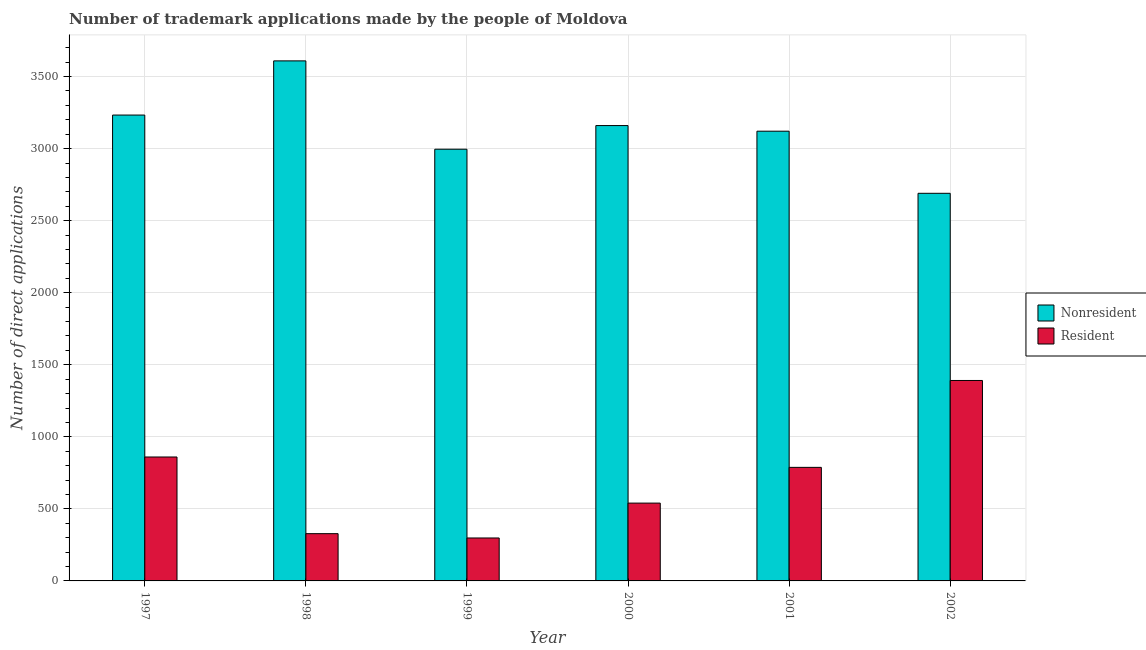Are the number of bars per tick equal to the number of legend labels?
Provide a succinct answer. Yes. Are the number of bars on each tick of the X-axis equal?
Offer a very short reply. Yes. How many bars are there on the 6th tick from the left?
Give a very brief answer. 2. How many bars are there on the 1st tick from the right?
Your answer should be very brief. 2. In how many cases, is the number of bars for a given year not equal to the number of legend labels?
Make the answer very short. 0. What is the number of trademark applications made by residents in 1998?
Your answer should be very brief. 328. Across all years, what is the maximum number of trademark applications made by residents?
Offer a very short reply. 1391. Across all years, what is the minimum number of trademark applications made by residents?
Provide a short and direct response. 298. In which year was the number of trademark applications made by residents minimum?
Give a very brief answer. 1999. What is the total number of trademark applications made by residents in the graph?
Give a very brief answer. 4205. What is the difference between the number of trademark applications made by non residents in 1998 and that in 2001?
Offer a very short reply. 488. What is the difference between the number of trademark applications made by non residents in 2000 and the number of trademark applications made by residents in 1998?
Offer a very short reply. -449. What is the average number of trademark applications made by non residents per year?
Offer a terse response. 3134.83. In how many years, is the number of trademark applications made by non residents greater than 1700?
Give a very brief answer. 6. What is the ratio of the number of trademark applications made by residents in 1999 to that in 2000?
Your answer should be compact. 0.55. What is the difference between the highest and the second highest number of trademark applications made by non residents?
Your response must be concise. 376. What is the difference between the highest and the lowest number of trademark applications made by residents?
Provide a succinct answer. 1093. Is the sum of the number of trademark applications made by residents in 1997 and 2001 greater than the maximum number of trademark applications made by non residents across all years?
Your response must be concise. Yes. What does the 2nd bar from the left in 1997 represents?
Keep it short and to the point. Resident. What does the 2nd bar from the right in 2001 represents?
Offer a very short reply. Nonresident. Are all the bars in the graph horizontal?
Provide a short and direct response. No. How many years are there in the graph?
Make the answer very short. 6. Are the values on the major ticks of Y-axis written in scientific E-notation?
Your response must be concise. No. Where does the legend appear in the graph?
Provide a short and direct response. Center right. How are the legend labels stacked?
Give a very brief answer. Vertical. What is the title of the graph?
Offer a very short reply. Number of trademark applications made by the people of Moldova. What is the label or title of the X-axis?
Your response must be concise. Year. What is the label or title of the Y-axis?
Your answer should be very brief. Number of direct applications. What is the Number of direct applications in Nonresident in 1997?
Your response must be concise. 3233. What is the Number of direct applications in Resident in 1997?
Offer a terse response. 860. What is the Number of direct applications in Nonresident in 1998?
Keep it short and to the point. 3609. What is the Number of direct applications of Resident in 1998?
Provide a short and direct response. 328. What is the Number of direct applications in Nonresident in 1999?
Offer a very short reply. 2996. What is the Number of direct applications of Resident in 1999?
Give a very brief answer. 298. What is the Number of direct applications of Nonresident in 2000?
Offer a terse response. 3160. What is the Number of direct applications in Resident in 2000?
Your response must be concise. 540. What is the Number of direct applications in Nonresident in 2001?
Provide a succinct answer. 3121. What is the Number of direct applications in Resident in 2001?
Provide a succinct answer. 788. What is the Number of direct applications of Nonresident in 2002?
Your response must be concise. 2690. What is the Number of direct applications of Resident in 2002?
Your answer should be very brief. 1391. Across all years, what is the maximum Number of direct applications of Nonresident?
Your answer should be very brief. 3609. Across all years, what is the maximum Number of direct applications of Resident?
Make the answer very short. 1391. Across all years, what is the minimum Number of direct applications in Nonresident?
Your response must be concise. 2690. Across all years, what is the minimum Number of direct applications of Resident?
Your answer should be very brief. 298. What is the total Number of direct applications of Nonresident in the graph?
Make the answer very short. 1.88e+04. What is the total Number of direct applications in Resident in the graph?
Your answer should be very brief. 4205. What is the difference between the Number of direct applications of Nonresident in 1997 and that in 1998?
Your answer should be compact. -376. What is the difference between the Number of direct applications in Resident in 1997 and that in 1998?
Keep it short and to the point. 532. What is the difference between the Number of direct applications of Nonresident in 1997 and that in 1999?
Make the answer very short. 237. What is the difference between the Number of direct applications of Resident in 1997 and that in 1999?
Offer a terse response. 562. What is the difference between the Number of direct applications of Resident in 1997 and that in 2000?
Ensure brevity in your answer.  320. What is the difference between the Number of direct applications of Nonresident in 1997 and that in 2001?
Offer a terse response. 112. What is the difference between the Number of direct applications in Nonresident in 1997 and that in 2002?
Provide a succinct answer. 543. What is the difference between the Number of direct applications in Resident in 1997 and that in 2002?
Make the answer very short. -531. What is the difference between the Number of direct applications of Nonresident in 1998 and that in 1999?
Make the answer very short. 613. What is the difference between the Number of direct applications of Nonresident in 1998 and that in 2000?
Your answer should be very brief. 449. What is the difference between the Number of direct applications of Resident in 1998 and that in 2000?
Your answer should be very brief. -212. What is the difference between the Number of direct applications of Nonresident in 1998 and that in 2001?
Give a very brief answer. 488. What is the difference between the Number of direct applications in Resident in 1998 and that in 2001?
Offer a very short reply. -460. What is the difference between the Number of direct applications of Nonresident in 1998 and that in 2002?
Keep it short and to the point. 919. What is the difference between the Number of direct applications in Resident in 1998 and that in 2002?
Your answer should be compact. -1063. What is the difference between the Number of direct applications in Nonresident in 1999 and that in 2000?
Your response must be concise. -164. What is the difference between the Number of direct applications of Resident in 1999 and that in 2000?
Provide a succinct answer. -242. What is the difference between the Number of direct applications in Nonresident in 1999 and that in 2001?
Ensure brevity in your answer.  -125. What is the difference between the Number of direct applications in Resident in 1999 and that in 2001?
Offer a very short reply. -490. What is the difference between the Number of direct applications in Nonresident in 1999 and that in 2002?
Offer a terse response. 306. What is the difference between the Number of direct applications in Resident in 1999 and that in 2002?
Keep it short and to the point. -1093. What is the difference between the Number of direct applications of Resident in 2000 and that in 2001?
Your answer should be compact. -248. What is the difference between the Number of direct applications in Nonresident in 2000 and that in 2002?
Provide a short and direct response. 470. What is the difference between the Number of direct applications of Resident in 2000 and that in 2002?
Keep it short and to the point. -851. What is the difference between the Number of direct applications in Nonresident in 2001 and that in 2002?
Make the answer very short. 431. What is the difference between the Number of direct applications in Resident in 2001 and that in 2002?
Provide a succinct answer. -603. What is the difference between the Number of direct applications in Nonresident in 1997 and the Number of direct applications in Resident in 1998?
Offer a very short reply. 2905. What is the difference between the Number of direct applications of Nonresident in 1997 and the Number of direct applications of Resident in 1999?
Provide a succinct answer. 2935. What is the difference between the Number of direct applications in Nonresident in 1997 and the Number of direct applications in Resident in 2000?
Provide a short and direct response. 2693. What is the difference between the Number of direct applications in Nonresident in 1997 and the Number of direct applications in Resident in 2001?
Provide a succinct answer. 2445. What is the difference between the Number of direct applications in Nonresident in 1997 and the Number of direct applications in Resident in 2002?
Your response must be concise. 1842. What is the difference between the Number of direct applications of Nonresident in 1998 and the Number of direct applications of Resident in 1999?
Your response must be concise. 3311. What is the difference between the Number of direct applications of Nonresident in 1998 and the Number of direct applications of Resident in 2000?
Your response must be concise. 3069. What is the difference between the Number of direct applications of Nonresident in 1998 and the Number of direct applications of Resident in 2001?
Make the answer very short. 2821. What is the difference between the Number of direct applications in Nonresident in 1998 and the Number of direct applications in Resident in 2002?
Provide a succinct answer. 2218. What is the difference between the Number of direct applications in Nonresident in 1999 and the Number of direct applications in Resident in 2000?
Make the answer very short. 2456. What is the difference between the Number of direct applications in Nonresident in 1999 and the Number of direct applications in Resident in 2001?
Keep it short and to the point. 2208. What is the difference between the Number of direct applications in Nonresident in 1999 and the Number of direct applications in Resident in 2002?
Offer a terse response. 1605. What is the difference between the Number of direct applications in Nonresident in 2000 and the Number of direct applications in Resident in 2001?
Provide a succinct answer. 2372. What is the difference between the Number of direct applications of Nonresident in 2000 and the Number of direct applications of Resident in 2002?
Ensure brevity in your answer.  1769. What is the difference between the Number of direct applications of Nonresident in 2001 and the Number of direct applications of Resident in 2002?
Offer a very short reply. 1730. What is the average Number of direct applications of Nonresident per year?
Your answer should be very brief. 3134.83. What is the average Number of direct applications of Resident per year?
Your answer should be compact. 700.83. In the year 1997, what is the difference between the Number of direct applications of Nonresident and Number of direct applications of Resident?
Provide a short and direct response. 2373. In the year 1998, what is the difference between the Number of direct applications of Nonresident and Number of direct applications of Resident?
Provide a short and direct response. 3281. In the year 1999, what is the difference between the Number of direct applications of Nonresident and Number of direct applications of Resident?
Keep it short and to the point. 2698. In the year 2000, what is the difference between the Number of direct applications of Nonresident and Number of direct applications of Resident?
Provide a short and direct response. 2620. In the year 2001, what is the difference between the Number of direct applications in Nonresident and Number of direct applications in Resident?
Provide a succinct answer. 2333. In the year 2002, what is the difference between the Number of direct applications in Nonresident and Number of direct applications in Resident?
Your answer should be very brief. 1299. What is the ratio of the Number of direct applications of Nonresident in 1997 to that in 1998?
Offer a terse response. 0.9. What is the ratio of the Number of direct applications in Resident in 1997 to that in 1998?
Provide a succinct answer. 2.62. What is the ratio of the Number of direct applications of Nonresident in 1997 to that in 1999?
Ensure brevity in your answer.  1.08. What is the ratio of the Number of direct applications in Resident in 1997 to that in 1999?
Your response must be concise. 2.89. What is the ratio of the Number of direct applications of Nonresident in 1997 to that in 2000?
Give a very brief answer. 1.02. What is the ratio of the Number of direct applications in Resident in 1997 to that in 2000?
Your answer should be compact. 1.59. What is the ratio of the Number of direct applications in Nonresident in 1997 to that in 2001?
Provide a short and direct response. 1.04. What is the ratio of the Number of direct applications in Resident in 1997 to that in 2001?
Your answer should be very brief. 1.09. What is the ratio of the Number of direct applications of Nonresident in 1997 to that in 2002?
Your answer should be very brief. 1.2. What is the ratio of the Number of direct applications of Resident in 1997 to that in 2002?
Give a very brief answer. 0.62. What is the ratio of the Number of direct applications of Nonresident in 1998 to that in 1999?
Give a very brief answer. 1.2. What is the ratio of the Number of direct applications in Resident in 1998 to that in 1999?
Your answer should be compact. 1.1. What is the ratio of the Number of direct applications of Nonresident in 1998 to that in 2000?
Keep it short and to the point. 1.14. What is the ratio of the Number of direct applications of Resident in 1998 to that in 2000?
Your response must be concise. 0.61. What is the ratio of the Number of direct applications of Nonresident in 1998 to that in 2001?
Offer a terse response. 1.16. What is the ratio of the Number of direct applications of Resident in 1998 to that in 2001?
Provide a succinct answer. 0.42. What is the ratio of the Number of direct applications in Nonresident in 1998 to that in 2002?
Provide a succinct answer. 1.34. What is the ratio of the Number of direct applications in Resident in 1998 to that in 2002?
Provide a succinct answer. 0.24. What is the ratio of the Number of direct applications of Nonresident in 1999 to that in 2000?
Your answer should be very brief. 0.95. What is the ratio of the Number of direct applications of Resident in 1999 to that in 2000?
Your response must be concise. 0.55. What is the ratio of the Number of direct applications in Nonresident in 1999 to that in 2001?
Give a very brief answer. 0.96. What is the ratio of the Number of direct applications of Resident in 1999 to that in 2001?
Offer a terse response. 0.38. What is the ratio of the Number of direct applications in Nonresident in 1999 to that in 2002?
Give a very brief answer. 1.11. What is the ratio of the Number of direct applications in Resident in 1999 to that in 2002?
Provide a succinct answer. 0.21. What is the ratio of the Number of direct applications of Nonresident in 2000 to that in 2001?
Ensure brevity in your answer.  1.01. What is the ratio of the Number of direct applications in Resident in 2000 to that in 2001?
Provide a short and direct response. 0.69. What is the ratio of the Number of direct applications of Nonresident in 2000 to that in 2002?
Keep it short and to the point. 1.17. What is the ratio of the Number of direct applications in Resident in 2000 to that in 2002?
Your answer should be very brief. 0.39. What is the ratio of the Number of direct applications in Nonresident in 2001 to that in 2002?
Offer a terse response. 1.16. What is the ratio of the Number of direct applications of Resident in 2001 to that in 2002?
Your answer should be very brief. 0.57. What is the difference between the highest and the second highest Number of direct applications in Nonresident?
Ensure brevity in your answer.  376. What is the difference between the highest and the second highest Number of direct applications of Resident?
Keep it short and to the point. 531. What is the difference between the highest and the lowest Number of direct applications in Nonresident?
Provide a succinct answer. 919. What is the difference between the highest and the lowest Number of direct applications of Resident?
Offer a very short reply. 1093. 